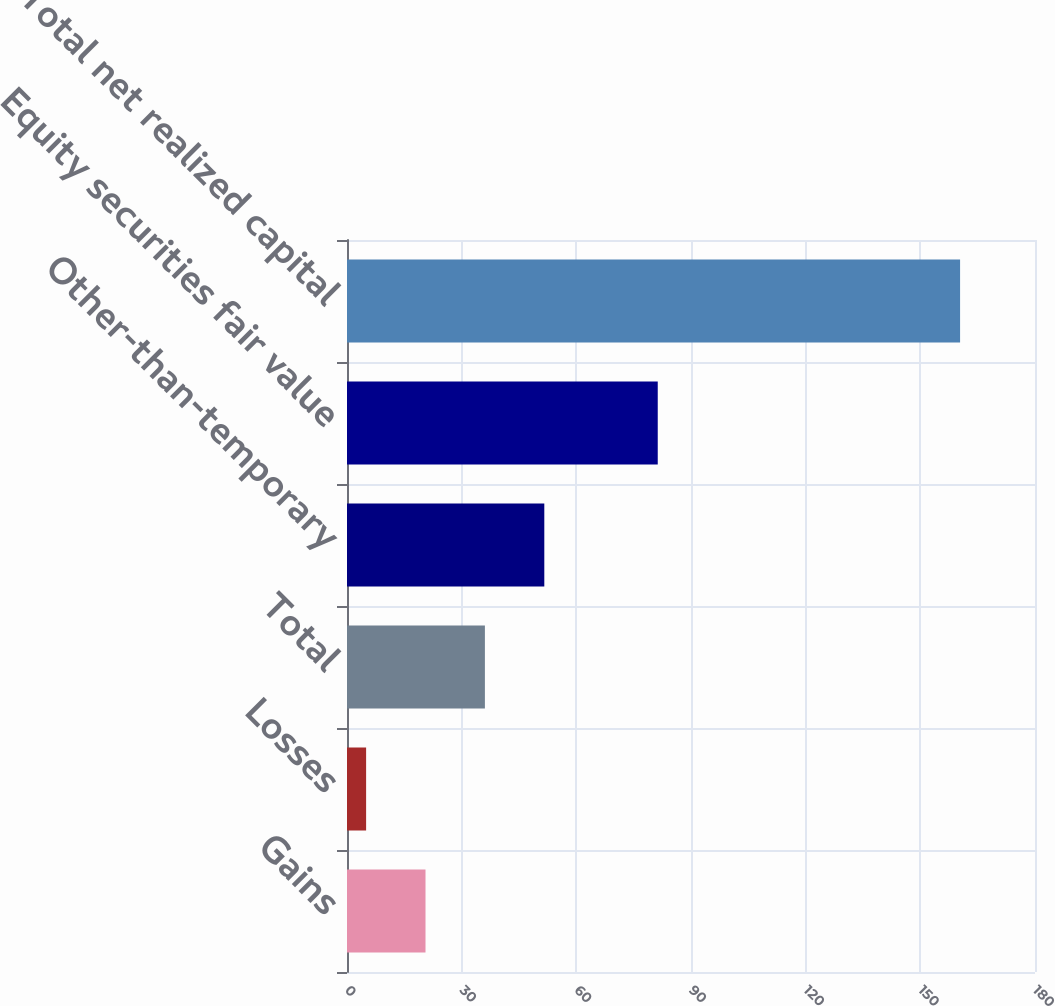Convert chart. <chart><loc_0><loc_0><loc_500><loc_500><bar_chart><fcel>Gains<fcel>Losses<fcel>Total<fcel>Other-than-temporary<fcel>Equity securities fair value<fcel>Total net realized capital<nl><fcel>20.54<fcel>5<fcel>36.08<fcel>51.62<fcel>81.3<fcel>160.4<nl></chart> 